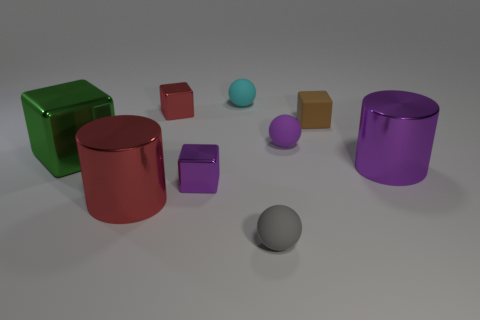Is the large green object made of the same material as the large object that is right of the small gray rubber sphere?
Your answer should be compact. Yes. Are there fewer small cyan objects that are in front of the green metallic thing than big red metallic cylinders that are in front of the tiny matte block?
Give a very brief answer. Yes. There is another large cylinder that is made of the same material as the purple cylinder; what is its color?
Ensure brevity in your answer.  Red. Are there any cylinders that are on the left side of the purple thing on the left side of the cyan ball?
Provide a succinct answer. Yes. The matte cube that is the same size as the gray rubber sphere is what color?
Your answer should be compact. Brown. How many things are tiny brown matte cubes or tiny purple shiny objects?
Provide a succinct answer. 2. How big is the block that is to the right of the matte sphere that is in front of the big cylinder that is on the right side of the gray object?
Offer a terse response. Small. How many tiny cubes are made of the same material as the big green thing?
Provide a short and direct response. 2. How many objects are either tiny objects or red cubes on the right side of the green shiny object?
Provide a succinct answer. 6. There is a small matte sphere on the left side of the thing in front of the red shiny thing that is in front of the purple matte thing; what is its color?
Your answer should be very brief. Cyan. 